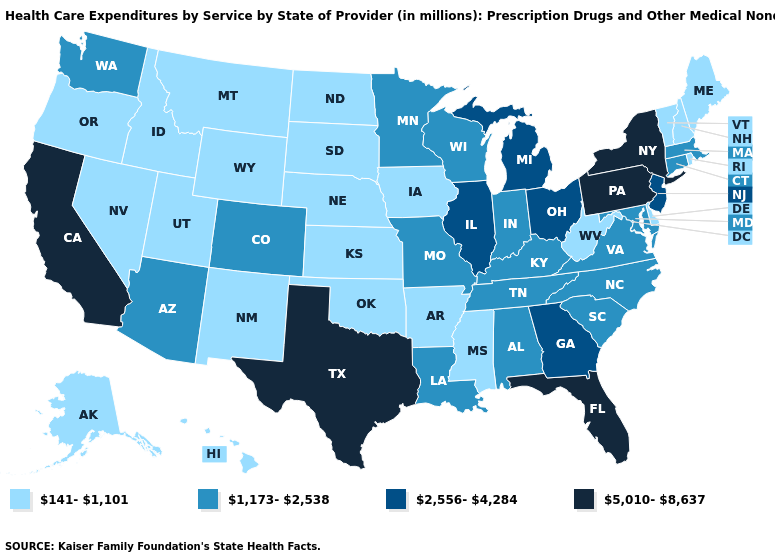What is the highest value in the MidWest ?
Quick response, please. 2,556-4,284. What is the value of Virginia?
Be succinct. 1,173-2,538. Name the states that have a value in the range 5,010-8,637?
Concise answer only. California, Florida, New York, Pennsylvania, Texas. What is the value of Nebraska?
Keep it brief. 141-1,101. Among the states that border West Virginia , which have the highest value?
Keep it brief. Pennsylvania. Does South Dakota have a lower value than West Virginia?
Quick response, please. No. What is the lowest value in states that border Florida?
Keep it brief. 1,173-2,538. Which states hav the highest value in the South?
Quick response, please. Florida, Texas. What is the value of New York?
Be succinct. 5,010-8,637. What is the highest value in the MidWest ?
Concise answer only. 2,556-4,284. What is the lowest value in the South?
Short answer required. 141-1,101. What is the value of North Dakota?
Concise answer only. 141-1,101. Does the map have missing data?
Keep it brief. No. What is the lowest value in states that border Oregon?
Quick response, please. 141-1,101. Is the legend a continuous bar?
Write a very short answer. No. 